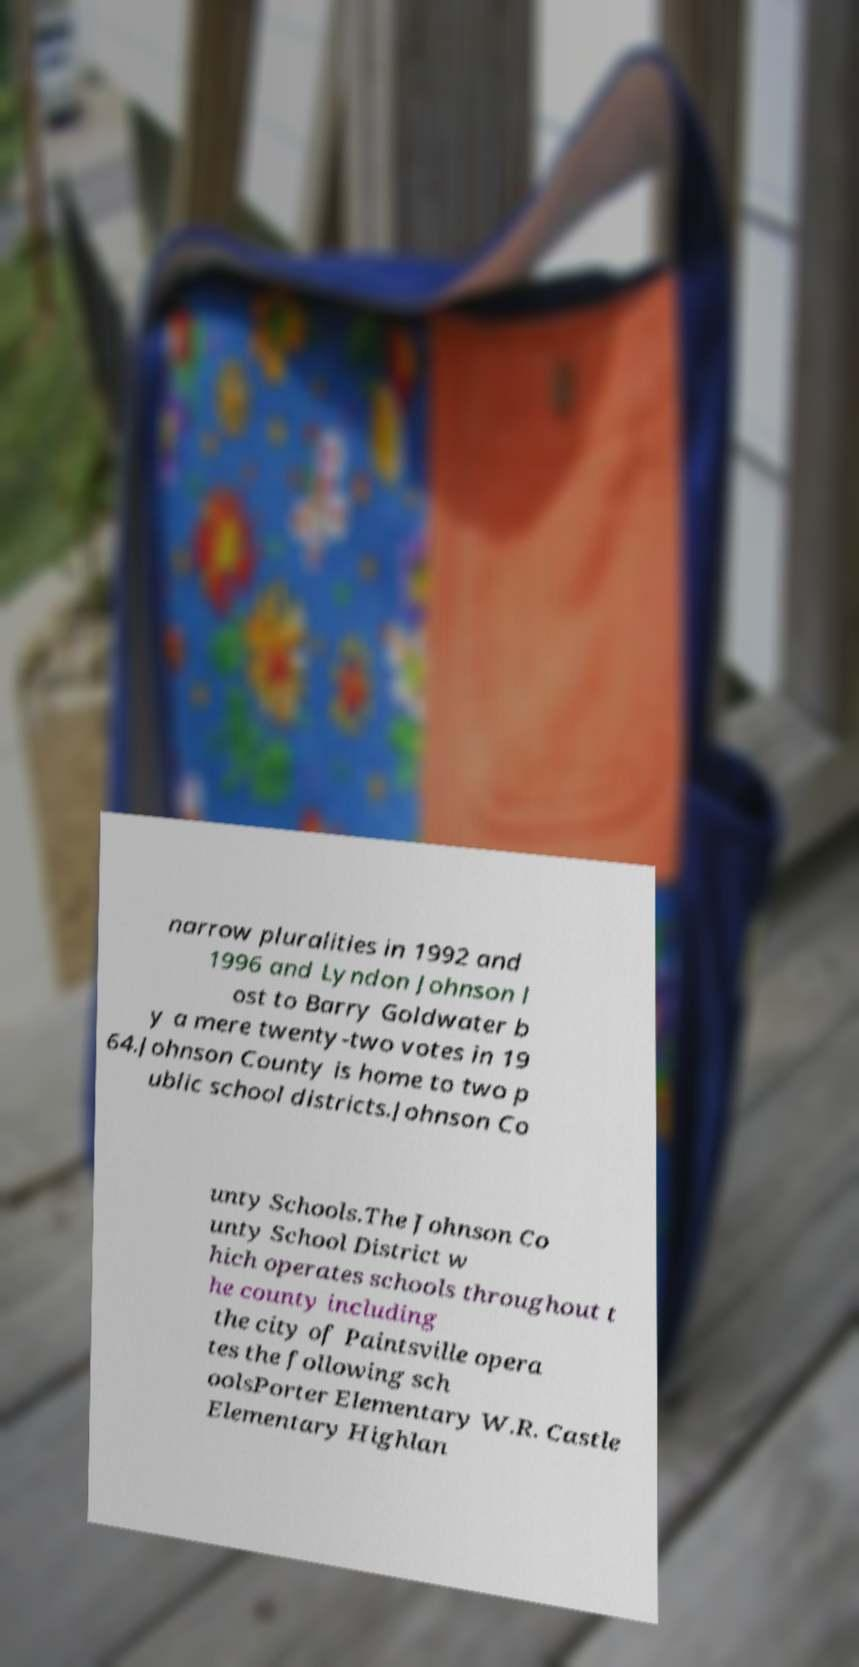What messages or text are displayed in this image? I need them in a readable, typed format. narrow pluralities in 1992 and 1996 and Lyndon Johnson l ost to Barry Goldwater b y a mere twenty-two votes in 19 64.Johnson County is home to two p ublic school districts.Johnson Co unty Schools.The Johnson Co unty School District w hich operates schools throughout t he county including the city of Paintsville opera tes the following sch oolsPorter Elementary W.R. Castle Elementary Highlan 